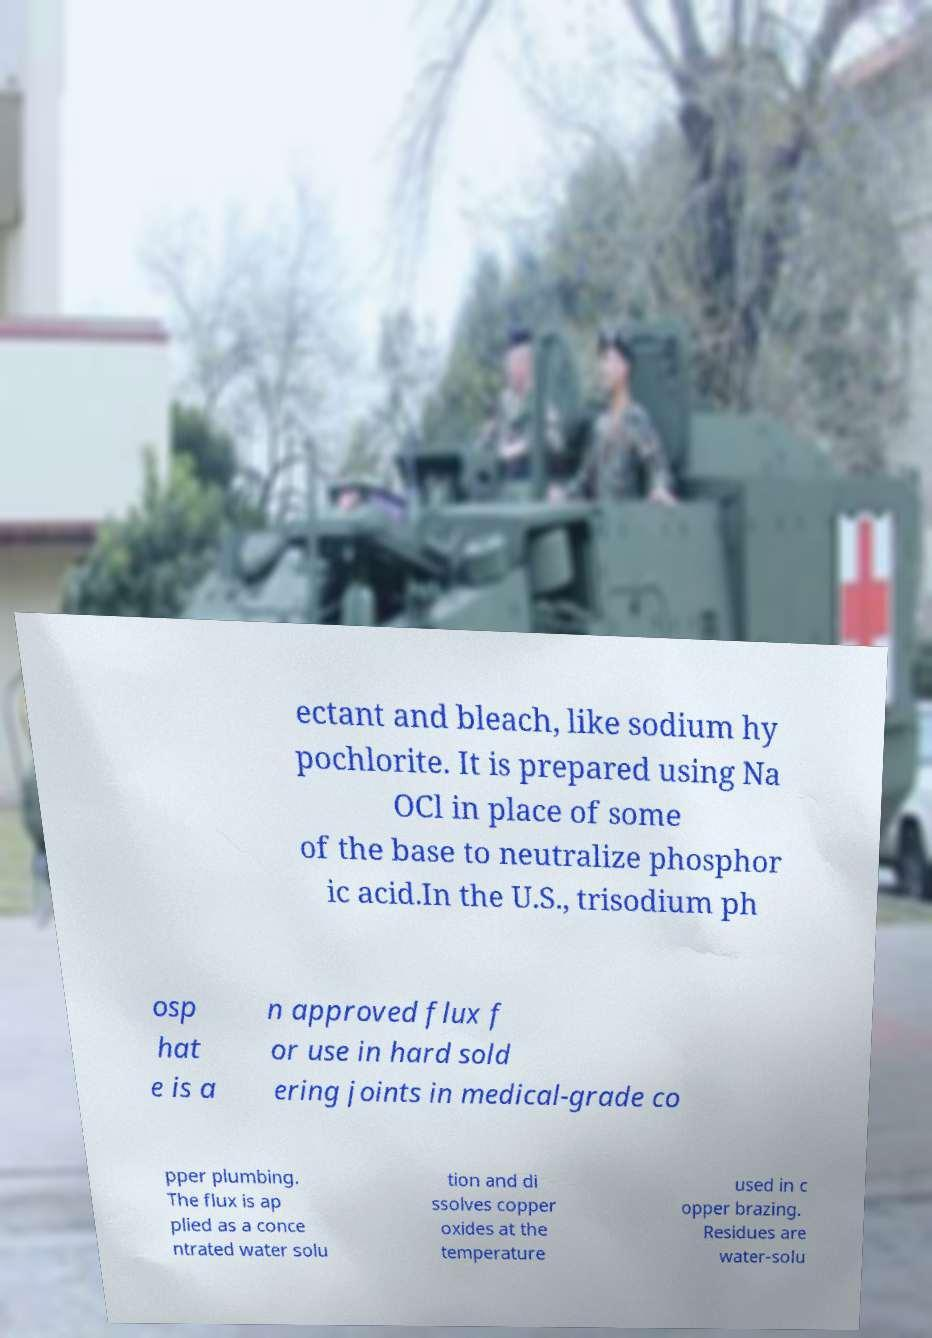For documentation purposes, I need the text within this image transcribed. Could you provide that? ectant and bleach, like sodium hy pochlorite. It is prepared using Na OCl in place of some of the base to neutralize phosphor ic acid.In the U.S., trisodium ph osp hat e is a n approved flux f or use in hard sold ering joints in medical-grade co pper plumbing. The flux is ap plied as a conce ntrated water solu tion and di ssolves copper oxides at the temperature used in c opper brazing. Residues are water-solu 